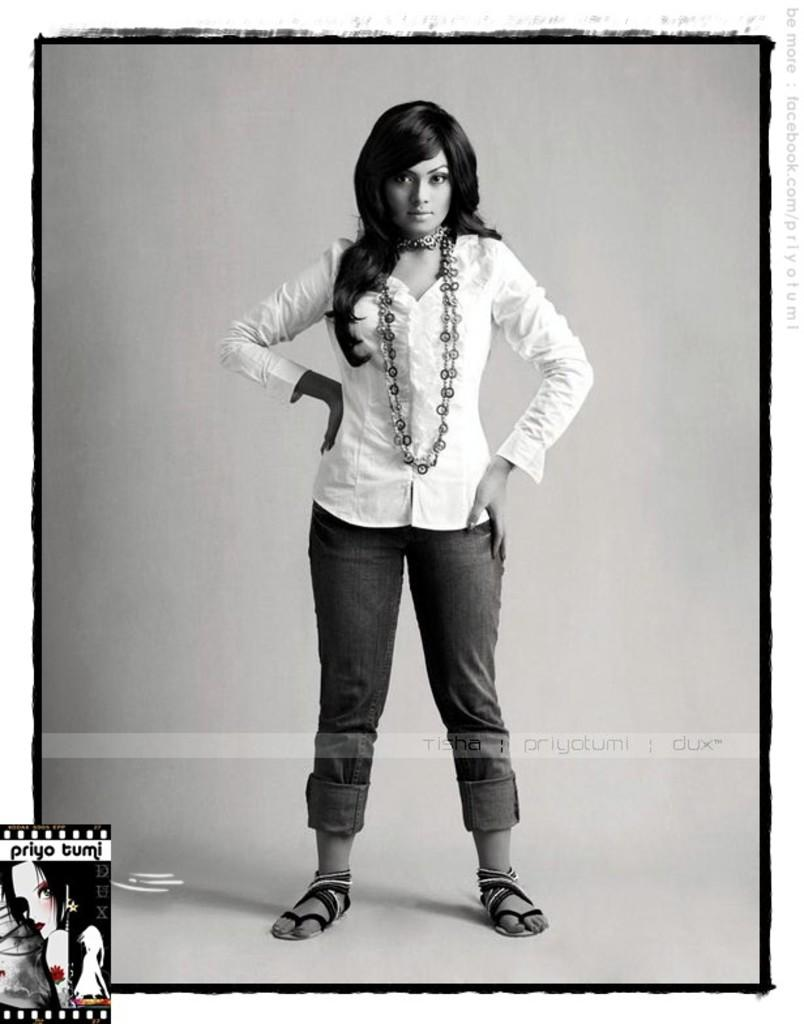What is the main subject of the picture? There is a woman standing in the center of the picture. What is the woman wearing? The woman is wearing a white dress. What can be seen around the picture? The picture has a black frame. Is there any text or symbol at the bottom of the picture? Yes, there is a logo at the bottom of the picture. What team does the woman belong to in the image? There is no indication of a team in the image; it only features a woman standing in a white dress with a black frame and a logo at the bottom. Can you tell me how the woman is blowing a bubble in the image? There is no bubble or blowing action depicted in the image. 